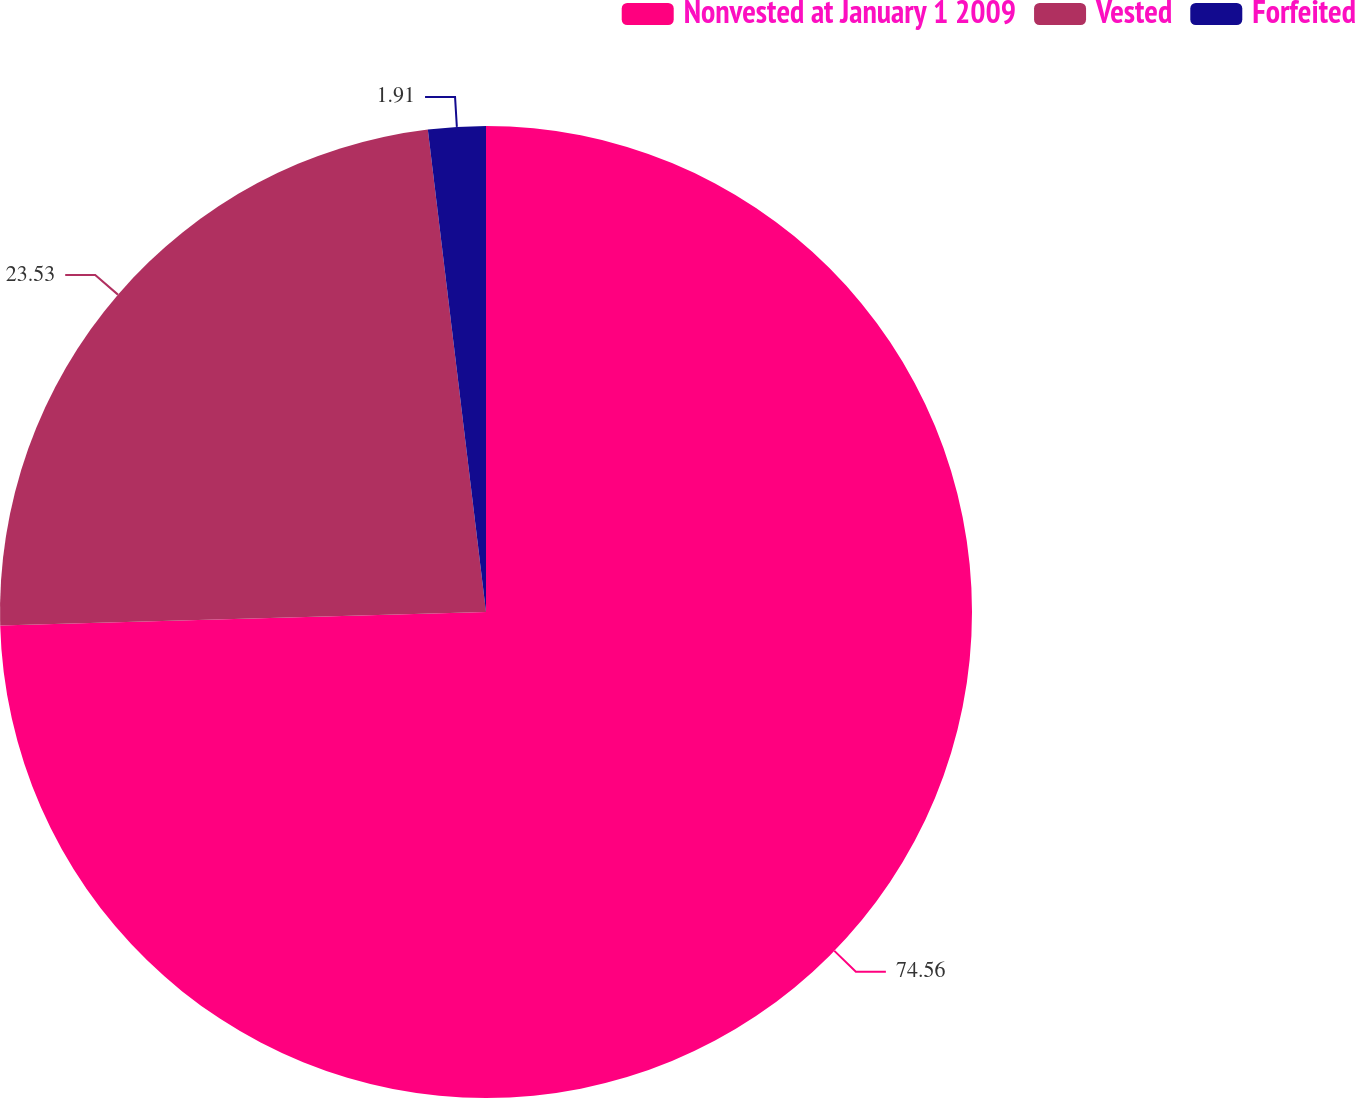<chart> <loc_0><loc_0><loc_500><loc_500><pie_chart><fcel>Nonvested at January 1 2009<fcel>Vested<fcel>Forfeited<nl><fcel>74.56%<fcel>23.53%<fcel>1.91%<nl></chart> 